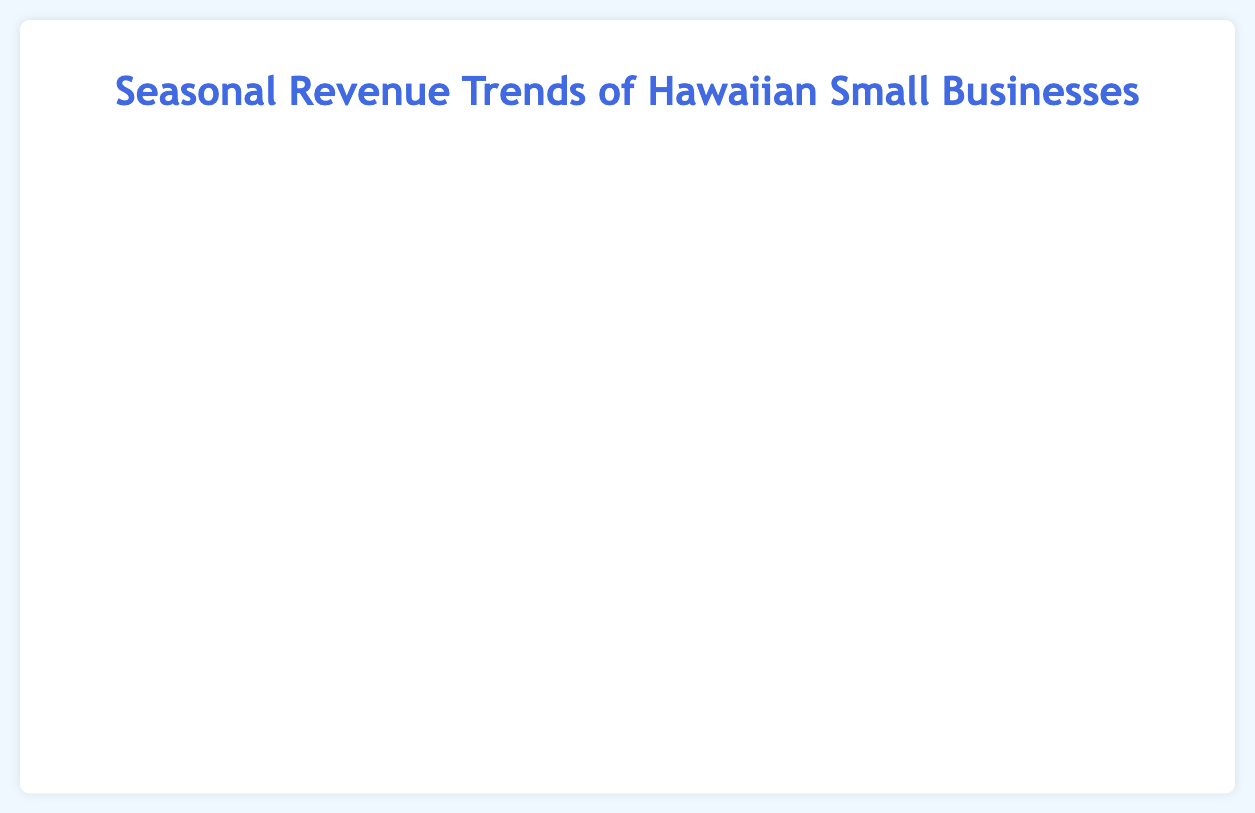What is the title of the chart? The title of the chart is usually displayed at the top and it helps viewers understand the overall topic of the figure. The title in this chart is "Seasonal Revenue Trends of Hawaiian Small Businesses."
Answer: Seasonal Revenue Trends of Hawaiian Small Businesses What's the overall trend for Aloha Surf Shop in different seasons? The positions of the bubbles related to Aloha Surf Shop on the chart show how revenue changes across different seasons. By following the y-values of these bubbles, we see that the revenue is low in Winter, increases in Spring, peaks in Summer, and then decreases in Fall.
Answer: Peaks in Summer, lowest in Winter Which business has the highest average sale value in any season? The average sale value is represented on the x-axis. By looking for the bubble farthest to the right, we see that "Island Tour Adventures" in Summer has the highest average sale value of 275.
Answer: Island Tour Adventures in Summer How many employees does Hawaiian BBQ Paradise have in Summer? The number of employees is tied to the size of the bubbles. By looking at the bubble size for "Hawaiian BBQ Paradise" in Summer, the size represents twice the number of employees. The radius is 20, so the number of employees is 10.
Answer: 10 Compare the revenue of Aloha Surf Shop in Winter and Summer. Aloha Surf Shop’s winter revenue is represented by the y-value of one bubble and its summer revenue by another bubble. The winter bubble is at $50,000 while the summer bubble is at $120,000.
Answer: Summer revenue is higher by $70,000 What's the average revenue for Tropical Handicrafts across all seasons? To find the average revenue, sum up the revenues for all four seasons and divide by the number of seasons. $(15,000 + 30,000 + 50,000 + 20,000) / 4 = 115,000 / 4$
Answer: $28,750 Which business experienced the highest revenue during Spring? To determine the highest revenue during Spring, we identify the highest y-value among the spring bubbles. "Aloha Surf Shop" in Spring has the highest revenue of $80,000.
Answer: Aloha Surf Shop Which season has the lowest overall bubble color density? The density of the bubbles' colors might visually vary, making it possible to estimate which season is the least represented. By looking at the chart's colors, Winter (light blue bubbles) appears the least dense.
Answer: Winter How many businesses have bubbles in the $30,000 to $40,000 revenue range? Identify the bubbles that fall between the y-values of $30,000 and $40,000. "Island Tour Adventures" (Winter), "Hawaiian BBQ Paradise" (Winter), and "Tropical Handicrafts" (Spring) meet this criterion.
Answer: 3 businesses What is the revenue difference between Hawaiian BBQ Paradise in Summer and Fall? Note the y-values for the bubbles representing Hawaiian BBQ Paradise in Summer and Fall. Summer revenue is $100,000 and Fall is $50,000. The difference is $100,000 - $50,000 = $50,000.
Answer: $50,000 